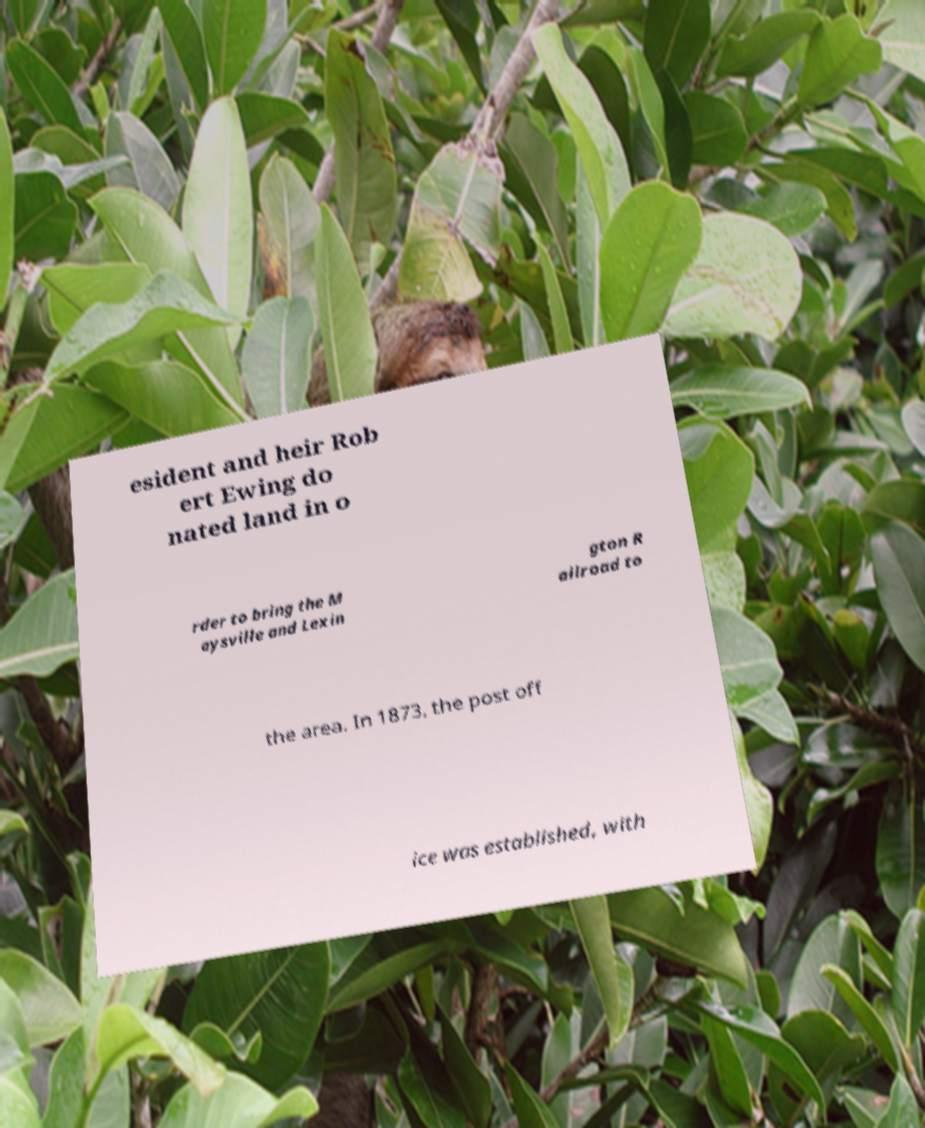There's text embedded in this image that I need extracted. Can you transcribe it verbatim? esident and heir Rob ert Ewing do nated land in o rder to bring the M aysville and Lexin gton R ailroad to the area. In 1873, the post off ice was established, with 